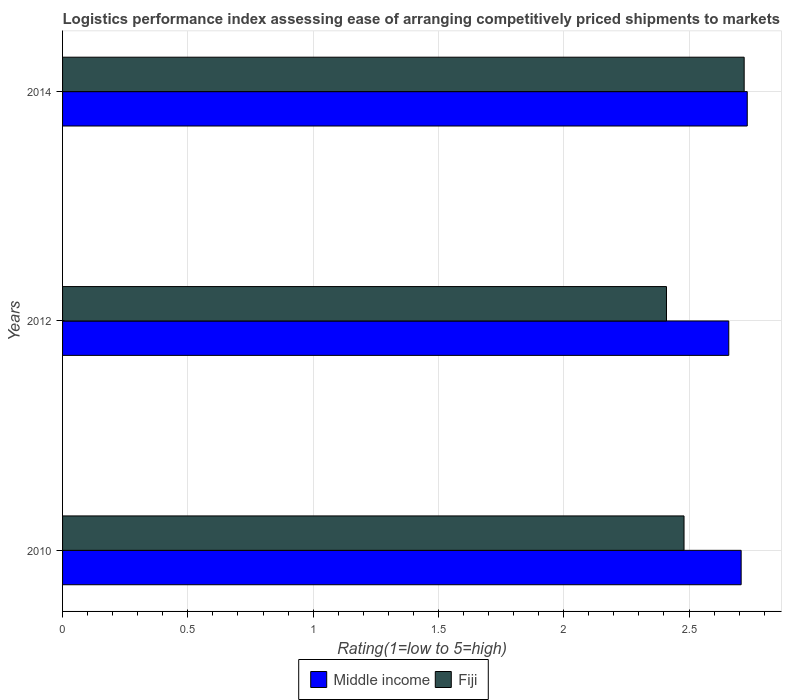How many different coloured bars are there?
Offer a very short reply. 2. How many groups of bars are there?
Give a very brief answer. 3. Are the number of bars on each tick of the Y-axis equal?
Keep it short and to the point. Yes. How many bars are there on the 1st tick from the top?
Offer a very short reply. 2. How many bars are there on the 1st tick from the bottom?
Your answer should be very brief. 2. In how many cases, is the number of bars for a given year not equal to the number of legend labels?
Give a very brief answer. 0. What is the Logistic performance index in Fiji in 2014?
Make the answer very short. 2.72. Across all years, what is the maximum Logistic performance index in Fiji?
Offer a terse response. 2.72. Across all years, what is the minimum Logistic performance index in Middle income?
Offer a very short reply. 2.66. In which year was the Logistic performance index in Middle income maximum?
Your response must be concise. 2014. In which year was the Logistic performance index in Fiji minimum?
Your response must be concise. 2012. What is the total Logistic performance index in Middle income in the graph?
Offer a terse response. 8.1. What is the difference between the Logistic performance index in Fiji in 2010 and that in 2014?
Give a very brief answer. -0.24. What is the difference between the Logistic performance index in Middle income in 2010 and the Logistic performance index in Fiji in 2012?
Offer a terse response. 0.3. What is the average Logistic performance index in Fiji per year?
Provide a succinct answer. 2.54. In the year 2012, what is the difference between the Logistic performance index in Middle income and Logistic performance index in Fiji?
Your response must be concise. 0.25. In how many years, is the Logistic performance index in Middle income greater than 0.5 ?
Ensure brevity in your answer.  3. What is the ratio of the Logistic performance index in Middle income in 2010 to that in 2014?
Keep it short and to the point. 0.99. Is the Logistic performance index in Middle income in 2010 less than that in 2012?
Keep it short and to the point. No. What is the difference between the highest and the second highest Logistic performance index in Middle income?
Your answer should be very brief. 0.02. What is the difference between the highest and the lowest Logistic performance index in Middle income?
Your answer should be very brief. 0.07. In how many years, is the Logistic performance index in Middle income greater than the average Logistic performance index in Middle income taken over all years?
Your answer should be very brief. 2. Is the sum of the Logistic performance index in Fiji in 2010 and 2014 greater than the maximum Logistic performance index in Middle income across all years?
Keep it short and to the point. Yes. What does the 2nd bar from the top in 2012 represents?
Offer a terse response. Middle income. What does the 2nd bar from the bottom in 2010 represents?
Your response must be concise. Fiji. Are all the bars in the graph horizontal?
Offer a terse response. Yes. What is the difference between two consecutive major ticks on the X-axis?
Provide a succinct answer. 0.5. Does the graph contain any zero values?
Your response must be concise. No. Where does the legend appear in the graph?
Offer a terse response. Bottom center. How many legend labels are there?
Offer a terse response. 2. What is the title of the graph?
Offer a very short reply. Logistics performance index assessing ease of arranging competitively priced shipments to markets. What is the label or title of the X-axis?
Offer a terse response. Rating(1=low to 5=high). What is the label or title of the Y-axis?
Keep it short and to the point. Years. What is the Rating(1=low to 5=high) of Middle income in 2010?
Provide a short and direct response. 2.71. What is the Rating(1=low to 5=high) of Fiji in 2010?
Your response must be concise. 2.48. What is the Rating(1=low to 5=high) in Middle income in 2012?
Your answer should be very brief. 2.66. What is the Rating(1=low to 5=high) in Fiji in 2012?
Your answer should be very brief. 2.41. What is the Rating(1=low to 5=high) in Middle income in 2014?
Keep it short and to the point. 2.73. What is the Rating(1=low to 5=high) in Fiji in 2014?
Provide a succinct answer. 2.72. Across all years, what is the maximum Rating(1=low to 5=high) in Middle income?
Offer a terse response. 2.73. Across all years, what is the maximum Rating(1=low to 5=high) of Fiji?
Your answer should be compact. 2.72. Across all years, what is the minimum Rating(1=low to 5=high) of Middle income?
Your answer should be compact. 2.66. Across all years, what is the minimum Rating(1=low to 5=high) in Fiji?
Your answer should be very brief. 2.41. What is the total Rating(1=low to 5=high) in Middle income in the graph?
Give a very brief answer. 8.1. What is the total Rating(1=low to 5=high) in Fiji in the graph?
Ensure brevity in your answer.  7.61. What is the difference between the Rating(1=low to 5=high) of Middle income in 2010 and that in 2012?
Your answer should be compact. 0.05. What is the difference between the Rating(1=low to 5=high) of Fiji in 2010 and that in 2012?
Offer a terse response. 0.07. What is the difference between the Rating(1=low to 5=high) in Middle income in 2010 and that in 2014?
Your response must be concise. -0.02. What is the difference between the Rating(1=low to 5=high) of Fiji in 2010 and that in 2014?
Your answer should be very brief. -0.24. What is the difference between the Rating(1=low to 5=high) in Middle income in 2012 and that in 2014?
Give a very brief answer. -0.07. What is the difference between the Rating(1=low to 5=high) in Fiji in 2012 and that in 2014?
Give a very brief answer. -0.31. What is the difference between the Rating(1=low to 5=high) of Middle income in 2010 and the Rating(1=low to 5=high) of Fiji in 2012?
Give a very brief answer. 0.3. What is the difference between the Rating(1=low to 5=high) of Middle income in 2010 and the Rating(1=low to 5=high) of Fiji in 2014?
Your answer should be very brief. -0.01. What is the difference between the Rating(1=low to 5=high) of Middle income in 2012 and the Rating(1=low to 5=high) of Fiji in 2014?
Your response must be concise. -0.06. What is the average Rating(1=low to 5=high) of Middle income per year?
Keep it short and to the point. 2.7. What is the average Rating(1=low to 5=high) of Fiji per year?
Offer a very short reply. 2.54. In the year 2010, what is the difference between the Rating(1=low to 5=high) of Middle income and Rating(1=low to 5=high) of Fiji?
Your answer should be very brief. 0.23. In the year 2012, what is the difference between the Rating(1=low to 5=high) in Middle income and Rating(1=low to 5=high) in Fiji?
Provide a short and direct response. 0.25. In the year 2014, what is the difference between the Rating(1=low to 5=high) in Middle income and Rating(1=low to 5=high) in Fiji?
Keep it short and to the point. 0.01. What is the ratio of the Rating(1=low to 5=high) of Middle income in 2010 to that in 2012?
Ensure brevity in your answer.  1.02. What is the ratio of the Rating(1=low to 5=high) of Fiji in 2010 to that in 2014?
Make the answer very short. 0.91. What is the ratio of the Rating(1=low to 5=high) of Fiji in 2012 to that in 2014?
Provide a short and direct response. 0.89. What is the difference between the highest and the second highest Rating(1=low to 5=high) in Middle income?
Give a very brief answer. 0.02. What is the difference between the highest and the second highest Rating(1=low to 5=high) of Fiji?
Ensure brevity in your answer.  0.24. What is the difference between the highest and the lowest Rating(1=low to 5=high) in Middle income?
Keep it short and to the point. 0.07. What is the difference between the highest and the lowest Rating(1=low to 5=high) in Fiji?
Provide a short and direct response. 0.31. 